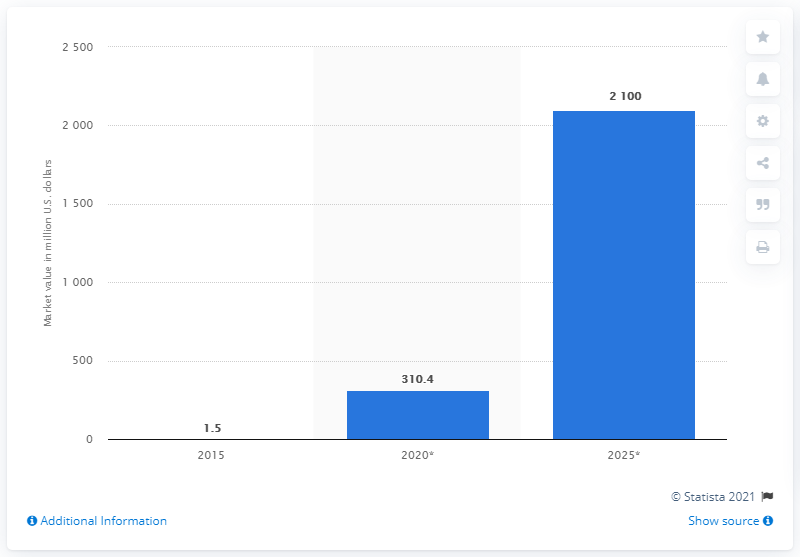Give some essential details in this illustration. The global market for graphene-based products was valued at approximately 1.5 billion dollars in 2015. The market for graphene-based products is expected to reach 310.4 million by 2020. 